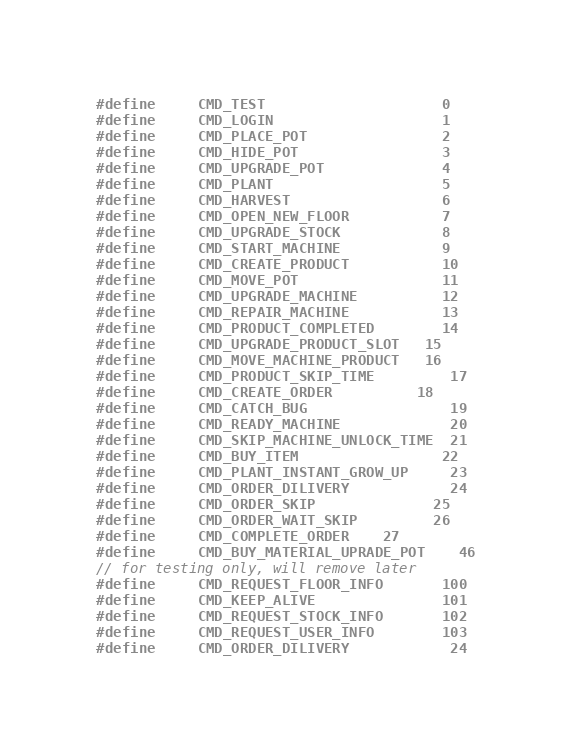<code> <loc_0><loc_0><loc_500><loc_500><_C_>#define     CMD_TEST                     0
#define     CMD_LOGIN                    1
#define     CMD_PLACE_POT                2
#define     CMD_HIDE_POT                 3
#define     CMD_UPGRADE_POT              4
#define     CMD_PLANT                    5
#define     CMD_HARVEST                  6
#define     CMD_OPEN_NEW_FLOOR           7
#define     CMD_UPGRADE_STOCK            8
#define     CMD_START_MACHINE            9
#define     CMD_CREATE_PRODUCT           10
#define     CMD_MOVE_POT                 11
#define     CMD_UPGRADE_MACHINE          12
#define     CMD_REPAIR_MACHINE           13
#define     CMD_PRODUCT_COMPLETED        14
#define     CMD_UPGRADE_PRODUCT_SLOT	  15
#define     CMD_MOVE_MACHINE_PRODUCT	  16
#define     CMD_PRODUCT_SKIP_TIME		 17
#define     CMD_CREATE_ORDER			 18
#define     CMD_CATCH_BUG				 19
#define     CMD_READY_MACHINE			 20
#define     CMD_SKIP_MACHINE_UNLOCK_TIME  21
#define     CMD_BUY_ITEM				    22
#define     CMD_PLANT_INSTANT_GROW_UP	 23
#define     CMD_ORDER_DILIVERY            24
#define     CMD_ORDER_SKIP              25
#define     CMD_ORDER_WAIT_SKIP         26
#define     CMD_COMPLETE_ORDER    27
#define     CMD_BUY_MATERIAL_UPRADE_POT    46
// for testing only, will remove later
#define     CMD_REQUEST_FLOOR_INFO       100
#define     CMD_KEEP_ALIVE               101
#define     CMD_REQUEST_STOCK_INFO       102
#define     CMD_REQUEST_USER_INFO        103
#define     CMD_ORDER_DILIVERY            24
</code> 